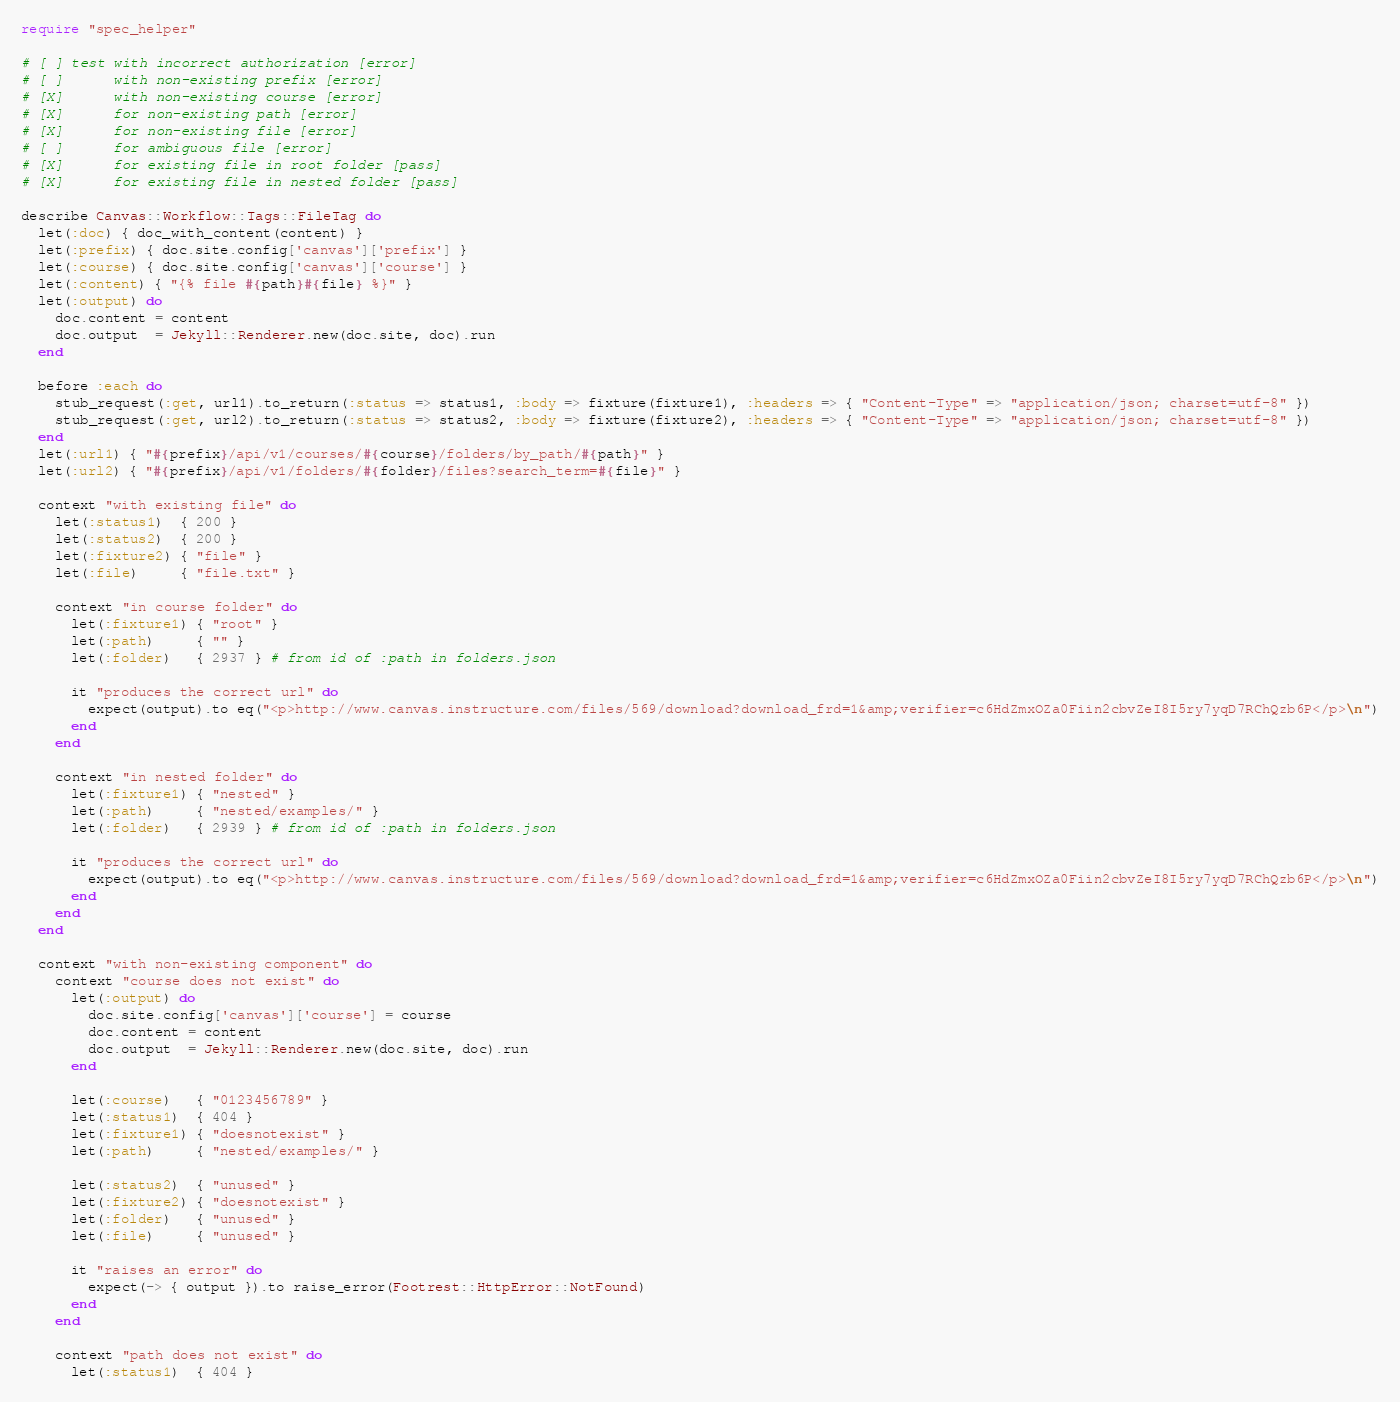Convert code to text. <code><loc_0><loc_0><loc_500><loc_500><_Ruby_>require "spec_helper"

# [ ] test with incorrect authorization [error]
# [ ]      with non-existing prefix [error]
# [X]      with non-existing course [error]
# [X]      for non-existing path [error]
# [X]      for non-existing file [error]
# [ ]      for ambiguous file [error]
# [X]      for existing file in root folder [pass]
# [X]      for existing file in nested folder [pass]

describe Canvas::Workflow::Tags::FileTag do
  let(:doc) { doc_with_content(content) }
  let(:prefix) { doc.site.config['canvas']['prefix'] }
  let(:course) { doc.site.config['canvas']['course'] }
  let(:content) { "{% file #{path}#{file} %}" }
  let(:output) do
    doc.content = content
    doc.output  = Jekyll::Renderer.new(doc.site, doc).run
  end

  before :each do
    stub_request(:get, url1).to_return(:status => status1, :body => fixture(fixture1), :headers => { "Content-Type" => "application/json; charset=utf-8" })
    stub_request(:get, url2).to_return(:status => status2, :body => fixture(fixture2), :headers => { "Content-Type" => "application/json; charset=utf-8" })
  end
  let(:url1) { "#{prefix}/api/v1/courses/#{course}/folders/by_path/#{path}" }
  let(:url2) { "#{prefix}/api/v1/folders/#{folder}/files?search_term=#{file}" }

  context "with existing file" do
    let(:status1)  { 200 }
    let(:status2)  { 200 }
    let(:fixture2) { "file" }
    let(:file)     { "file.txt" }

    context "in course folder" do
      let(:fixture1) { "root" }
      let(:path)     { "" }
      let(:folder)   { 2937 } # from id of :path in folders.json

      it "produces the correct url" do
        expect(output).to eq("<p>http://www.canvas.instructure.com/files/569/download?download_frd=1&amp;verifier=c6HdZmxOZa0Fiin2cbvZeI8I5ry7yqD7RChQzb6P</p>\n")
      end
    end

    context "in nested folder" do
      let(:fixture1) { "nested" }
      let(:path)     { "nested/examples/" }
      let(:folder)   { 2939 } # from id of :path in folders.json

      it "produces the correct url" do
        expect(output).to eq("<p>http://www.canvas.instructure.com/files/569/download?download_frd=1&amp;verifier=c6HdZmxOZa0Fiin2cbvZeI8I5ry7yqD7RChQzb6P</p>\n")
      end
    end
  end

  context "with non-existing component" do
    context "course does not exist" do
      let(:output) do
        doc.site.config['canvas']['course'] = course
        doc.content = content
        doc.output  = Jekyll::Renderer.new(doc.site, doc).run
      end

      let(:course)   { "0123456789" }
      let(:status1)  { 404 }
      let(:fixture1) { "doesnotexist" }
      let(:path)     { "nested/examples/" }

      let(:status2)  { "unused" }
      let(:fixture2) { "doesnotexist" }
      let(:folder)   { "unused" }
      let(:file)     { "unused" }

      it "raises an error" do
        expect(-> { output }).to raise_error(Footrest::HttpError::NotFound)
      end
    end

    context "path does not exist" do
      let(:status1)  { 404 }</code> 